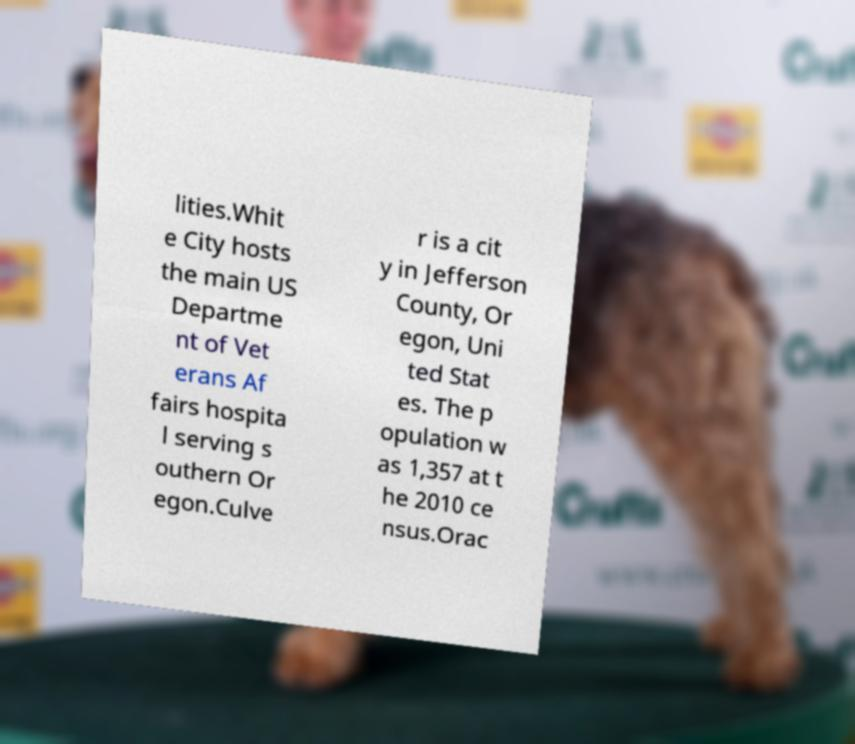Please identify and transcribe the text found in this image. lities.Whit e City hosts the main US Departme nt of Vet erans Af fairs hospita l serving s outhern Or egon.Culve r is a cit y in Jefferson County, Or egon, Uni ted Stat es. The p opulation w as 1,357 at t he 2010 ce nsus.Orac 